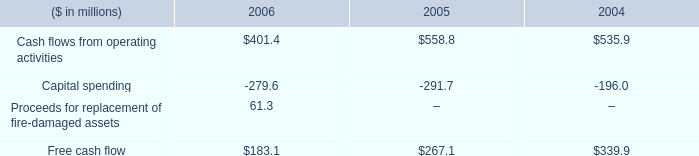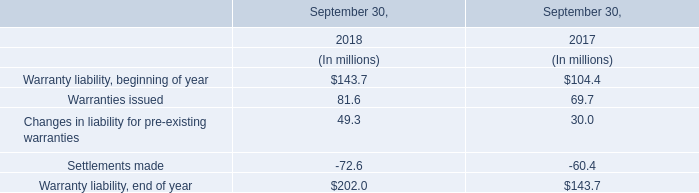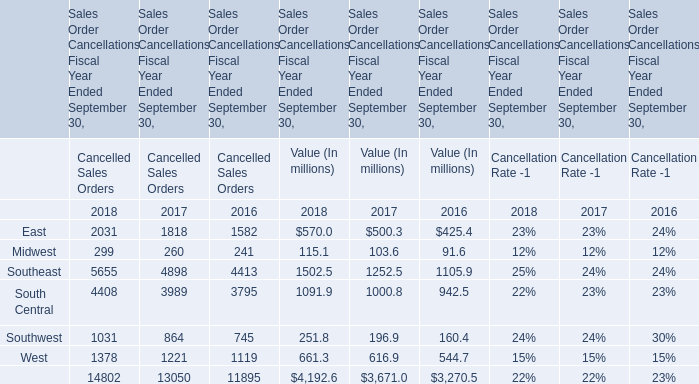What's the sum of the Southeast for Cancelled Sales Orders in the years where Changes in liability for pre-existing warranties is greater than 0? (in million) 
Computations: (5655 + 4898)
Answer: 10553.0. 